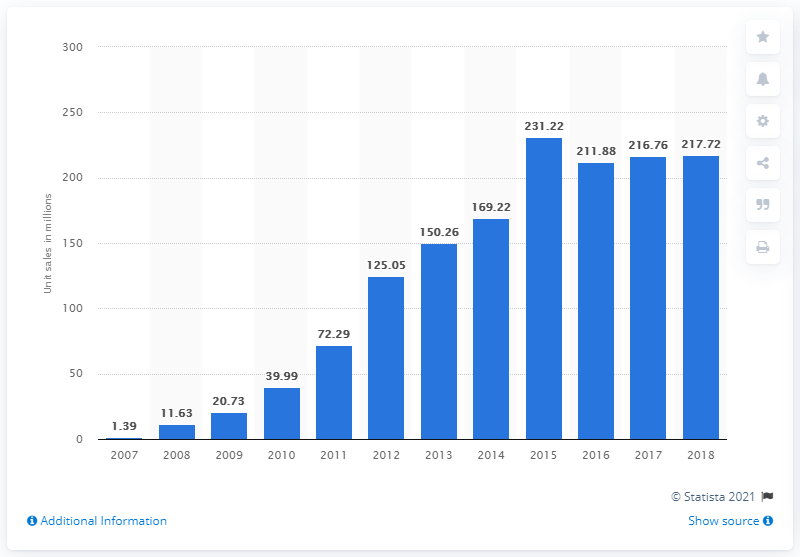Highlight a few significant elements in this photo. During their 2018 fiscal year, Apple sold a total of 217,720 iPhones. In 2015, a total of 231.22 iPhones were sold. The first iPhone was released in 2007. 